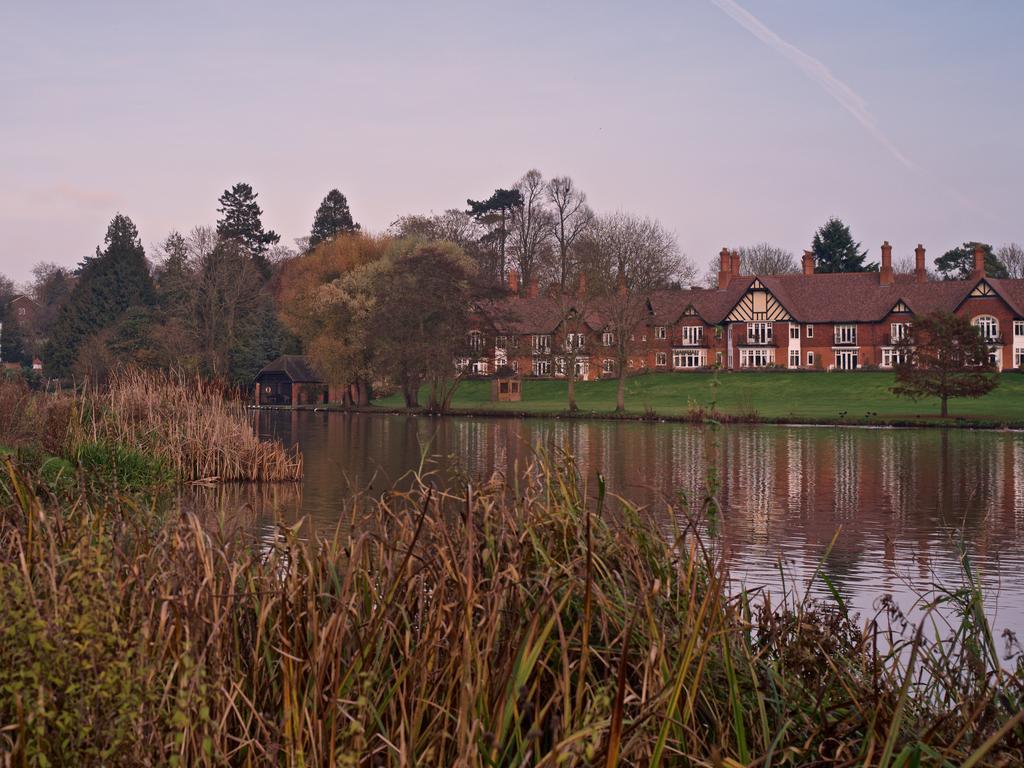In one or two sentences, can you explain what this image depicts? This image consists of plants. In the background, there are houses along with trees. At the bottom, there is green grass. In the middle, there is water. To the top, there is sky. 